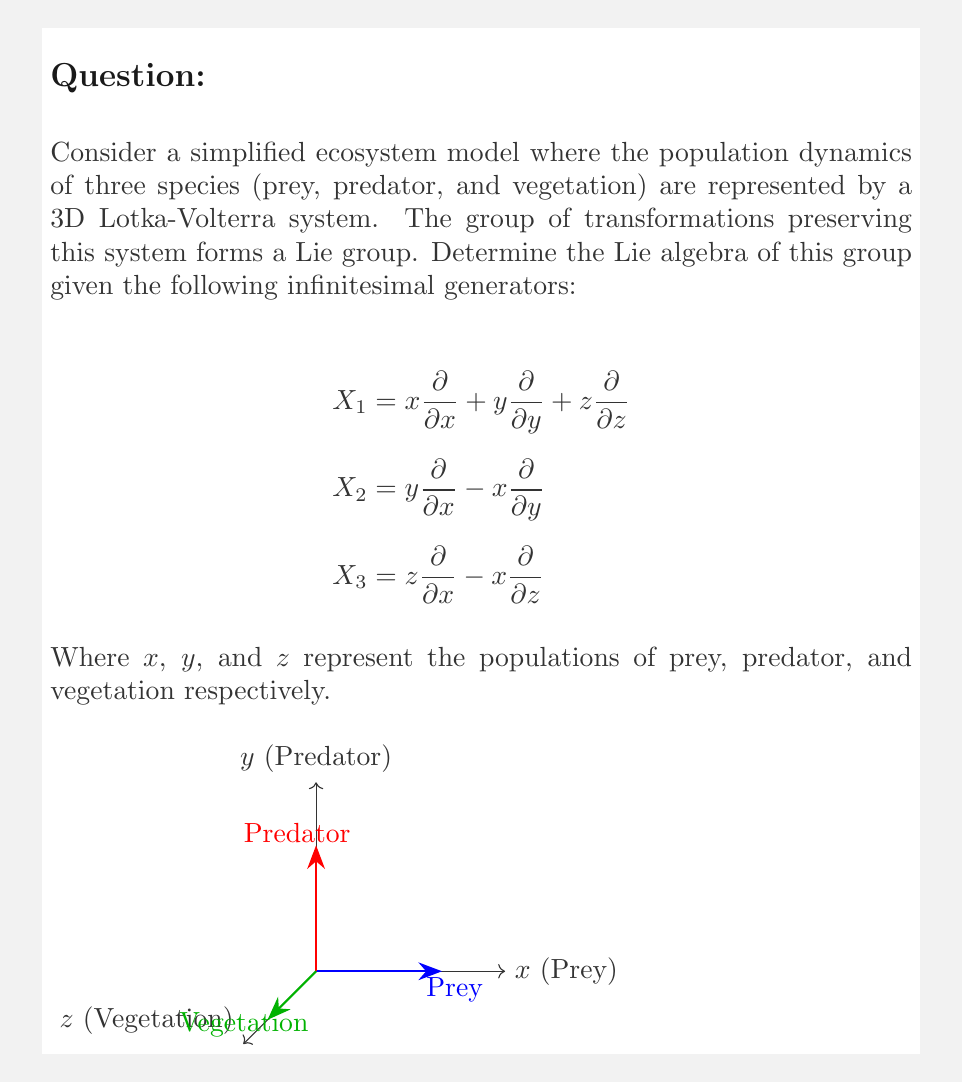What is the answer to this math problem? To determine the Lie algebra, we need to calculate the commutators of the given infinitesimal generators and check if they close under the Lie bracket operation.

Step 1: Calculate $[X_1, X_2]$
$$\begin{aligned}
[X_1, X_2] &= X_1X_2 - X_2X_1 \\
&= (x\frac{\partial}{\partial x} + y\frac{\partial}{\partial y} + z\frac{\partial}{\partial z})(y\frac{\partial}{\partial x} - x\frac{\partial}{\partial y}) \\
&\quad - (y\frac{\partial}{\partial x} - x\frac{\partial}{\partial y})(x\frac{\partial}{\partial x} + y\frac{\partial}{\partial y} + z\frac{\partial}{\partial z}) \\
&= y\frac{\partial}{\partial x} - x\frac{\partial}{\partial y} = X_2
\end{aligned}$$

Step 2: Calculate $[X_1, X_3]$
$$\begin{aligned}
[X_1, X_3] &= X_1X_3 - X_3X_1 \\
&= (x\frac{\partial}{\partial x} + y\frac{\partial}{\partial y} + z\frac{\partial}{\partial z})(z\frac{\partial}{\partial x} - x\frac{\partial}{\partial z}) \\
&\quad - (z\frac{\partial}{\partial x} - x\frac{\partial}{\partial z})(x\frac{\partial}{\partial x} + y\frac{\partial}{\partial y} + z\frac{\partial}{\partial z}) \\
&= z\frac{\partial}{\partial x} - x\frac{\partial}{\partial z} = X_3
\end{aligned}$$

Step 3: Calculate $[X_2, X_3]$
$$\begin{aligned}
[X_2, X_3] &= X_2X_3 - X_3X_2 \\
&= (y\frac{\partial}{\partial x} - x\frac{\partial}{\partial y})(z\frac{\partial}{\partial x} - x\frac{\partial}{\partial z}) \\
&\quad - (z\frac{\partial}{\partial x} - x\frac{\partial}{\partial z})(y\frac{\partial}{\partial x} - x\frac{\partial}{\partial y}) \\
&= -z\frac{\partial}{\partial y} + y\frac{\partial}{\partial z}
\end{aligned}$$

Let's denote $[X_2, X_3] = X_4 = -z\frac{\partial}{\partial y} + y\frac{\partial}{\partial z}$

Step 4: Check if $X_4$ commutes with the other generators
$$[X_1, X_4] = X_4$$
$$[X_2, X_4] = -X_3$$
$$[X_3, X_4] = X_2$$

We can see that the Lie bracket operations close within the span of $\{X_1, X_2, X_3, X_4\}$. Therefore, these four generators form a basis for the Lie algebra of the group representing the ecosystem dynamics.

The Lie algebra structure can be summarized by the following commutation relations:
$$[X_1, X_2] = X_2, \quad [X_1, X_3] = X_3, \quad [X_1, X_4] = X_4$$
$$[X_2, X_3] = X_4, \quad [X_2, X_4] = -X_3, \quad [X_3, X_4] = X_2$$
Answer: The Lie algebra is 4-dimensional, spanned by $\{X_1, X_2, X_3, X_4\}$ with $X_4 = -z\frac{\partial}{\partial y} + y\frac{\partial}{\partial z}$. 